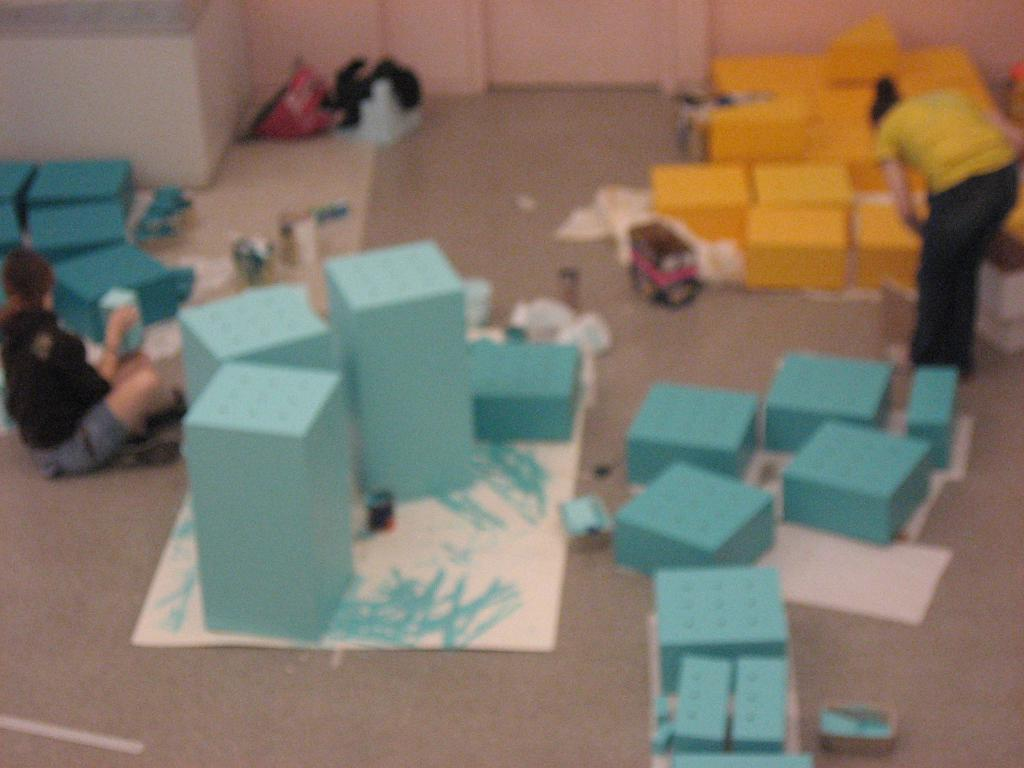What objects are on the floor in the image? There are cartons and papers on the floor. What are the people in the image doing? There are persons sitting and standing on the floor. What type of sponge can be seen in the image? There is no sponge present in the image. How does the person sitting on the floor care for the cartons? The image does not provide information about how the person sitting on the floor interacts with the cartons, so it cannot be determined from the image. 